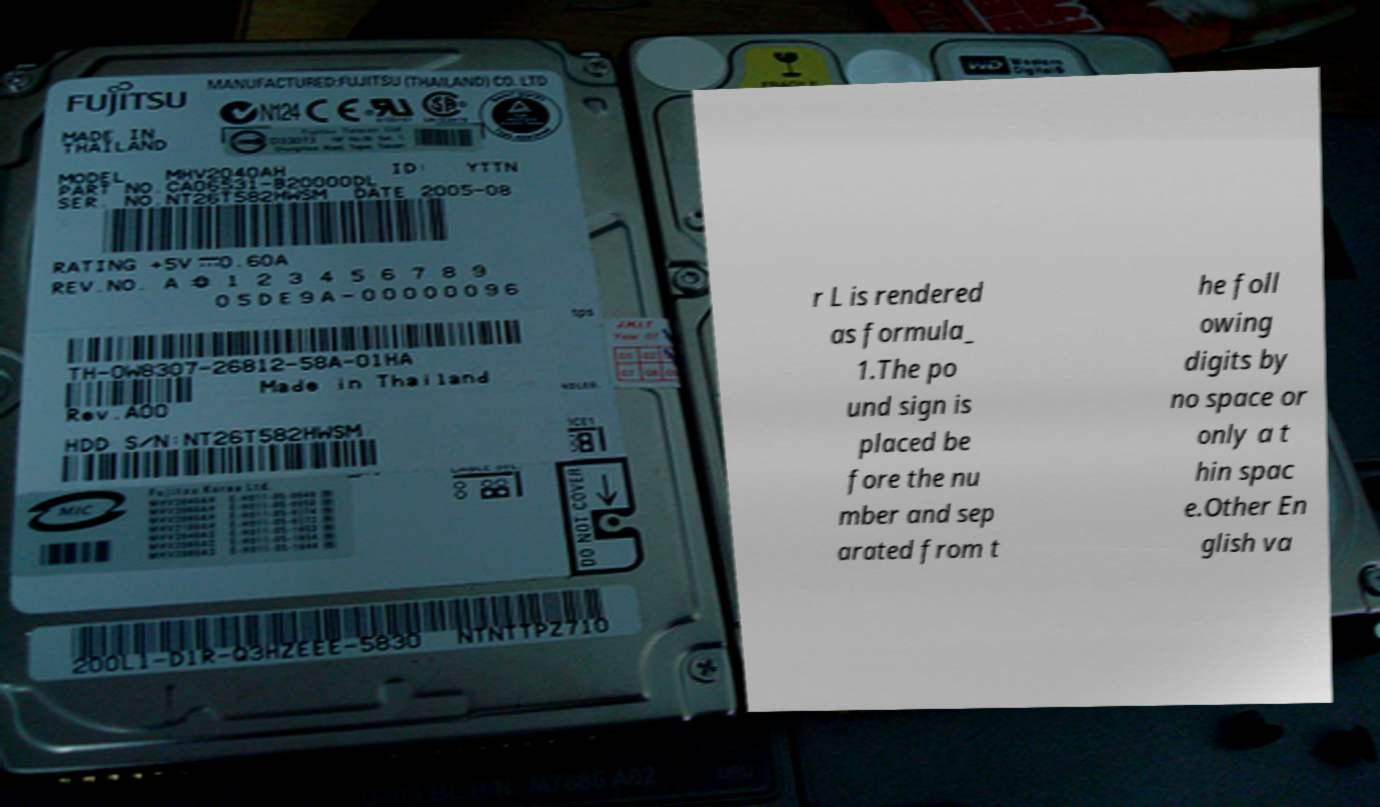What messages or text are displayed in this image? I need them in a readable, typed format. r L is rendered as formula_ 1.The po und sign is placed be fore the nu mber and sep arated from t he foll owing digits by no space or only a t hin spac e.Other En glish va 